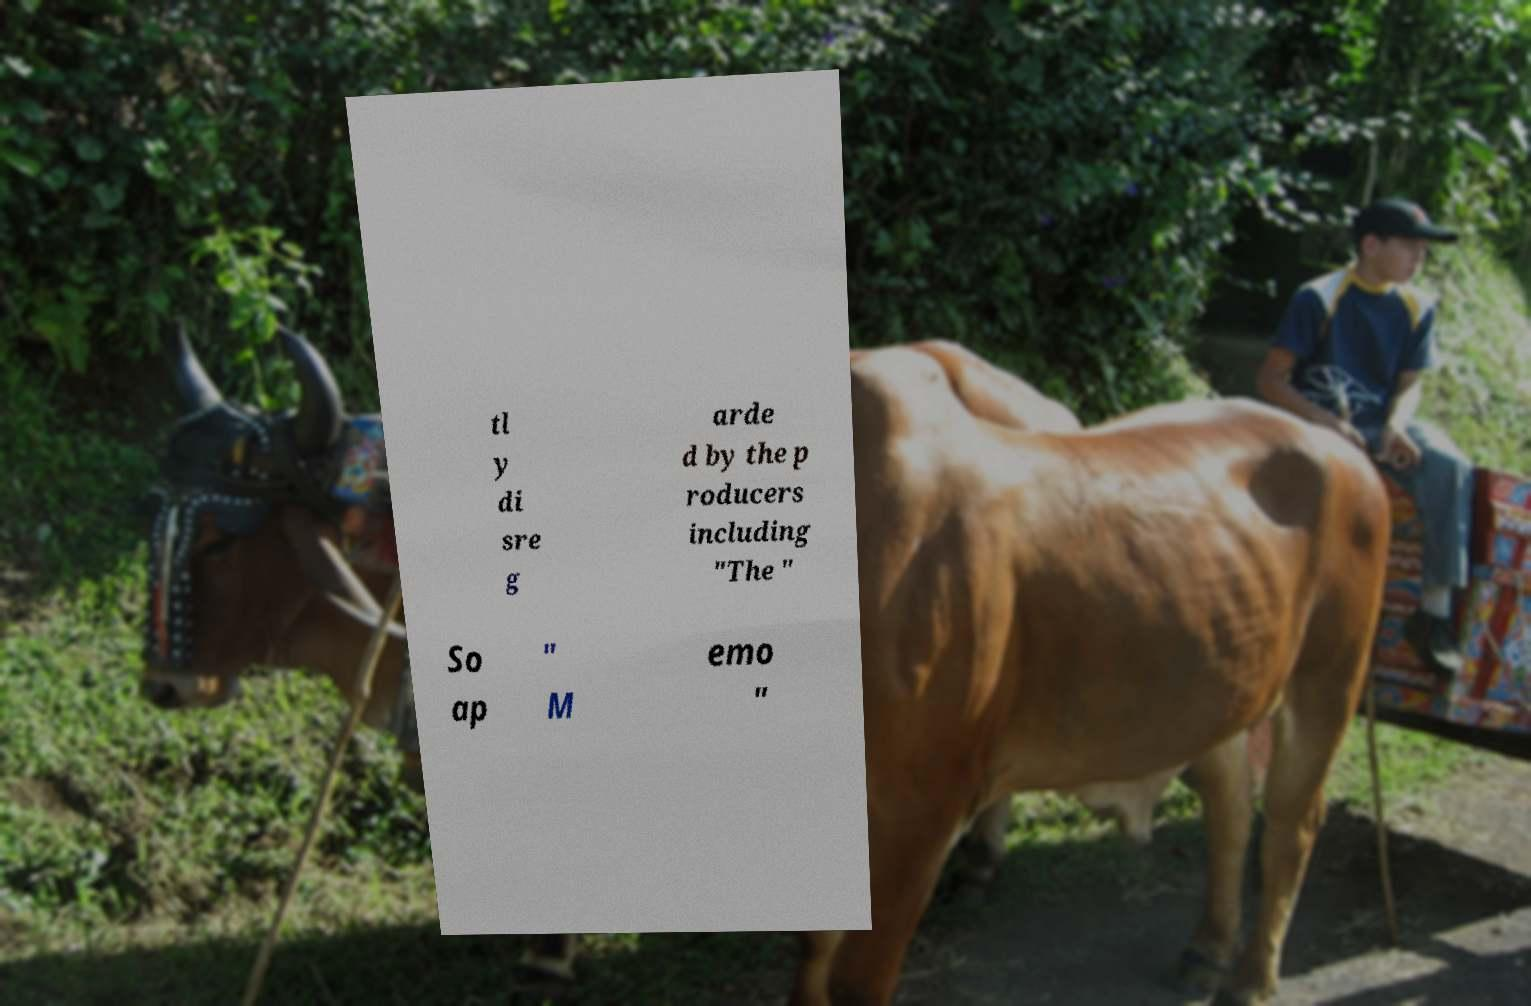Could you extract and type out the text from this image? tl y di sre g arde d by the p roducers including "The " So ap " M emo " 